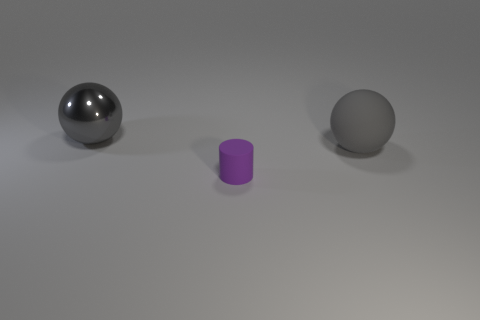Are there any other things that are the same size as the cylinder?
Offer a very short reply. No. There is a object that is behind the purple rubber object and in front of the gray metal ball; how big is it?
Your answer should be compact. Large. What number of other small cylinders have the same color as the tiny cylinder?
Offer a terse response. 0. There is another big thing that is the same color as the big matte thing; what is it made of?
Your answer should be very brief. Metal. Does the thing on the left side of the small purple rubber cylinder have the same material as the small purple object?
Give a very brief answer. No. What shape is the thing that is on the left side of the purple cylinder?
Your answer should be compact. Sphere. There is a object that is the same size as the rubber sphere; what material is it?
Provide a succinct answer. Metal. How many things are gray things that are right of the big gray metal object or gray spheres right of the tiny purple thing?
Your response must be concise. 1. What is the size of the gray thing that is the same material as the purple cylinder?
Offer a very short reply. Large. How many matte things are large spheres or small cylinders?
Your response must be concise. 2. 